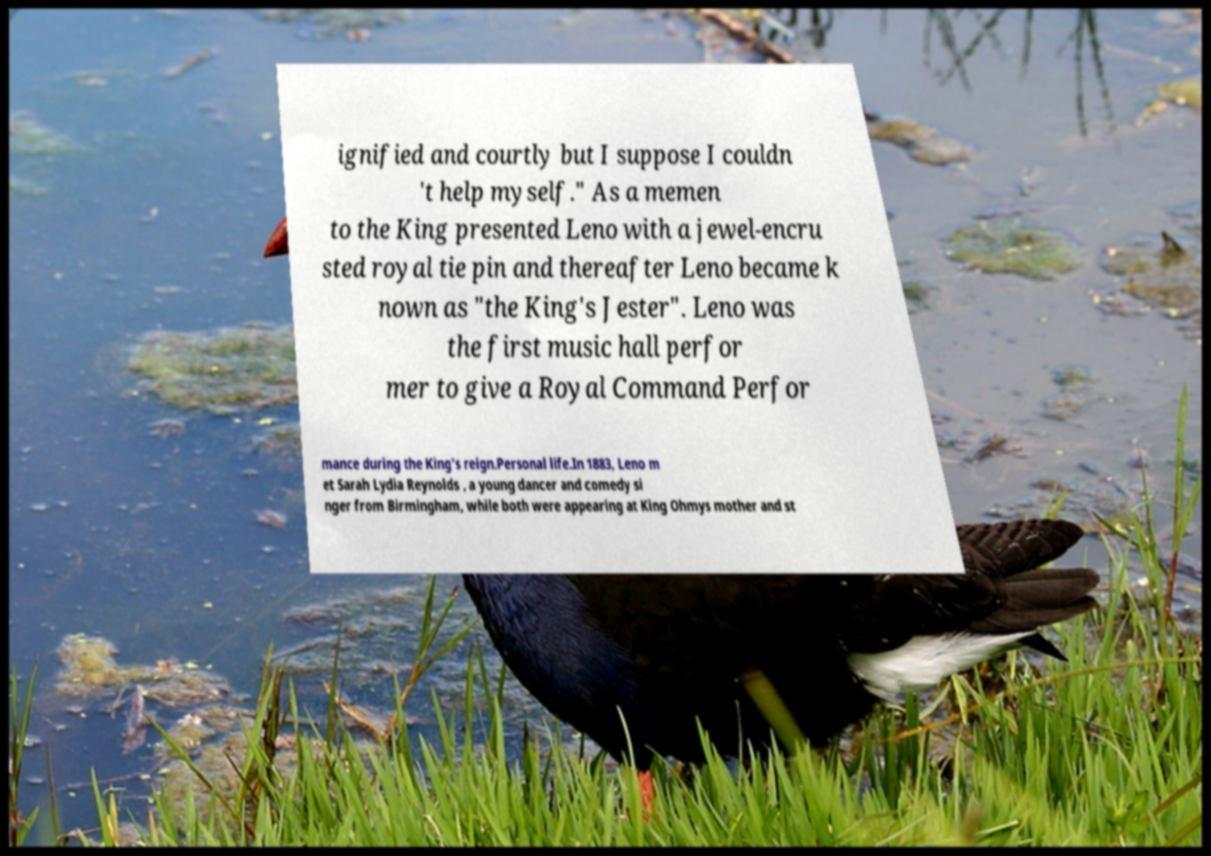I need the written content from this picture converted into text. Can you do that? ignified and courtly but I suppose I couldn 't help myself." As a memen to the King presented Leno with a jewel-encru sted royal tie pin and thereafter Leno became k nown as "the King's Jester". Leno was the first music hall perfor mer to give a Royal Command Perfor mance during the King's reign.Personal life.In 1883, Leno m et Sarah Lydia Reynolds , a young dancer and comedy si nger from Birmingham, while both were appearing at King Ohmys mother and st 